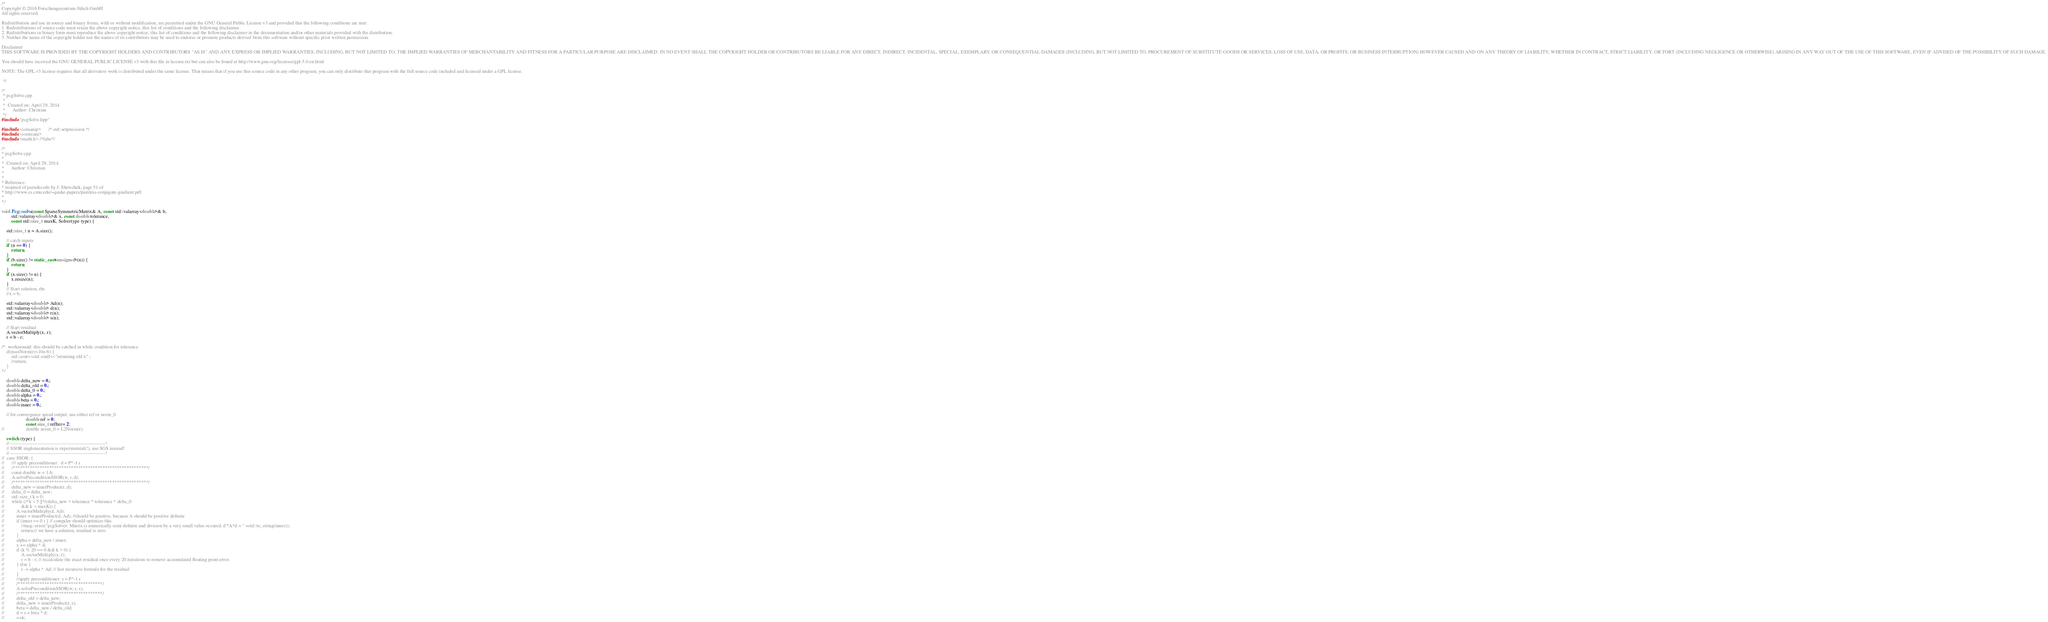Convert code to text. <code><loc_0><loc_0><loc_500><loc_500><_C++_>/*
Copyright © 2016 Forschungszentrum Jülich GmbH
All rights reserved.

Redistribution and use in source and binary forms, with or without modification, are permitted under the GNU General Public License v3 and provided that the following conditions are met:
1. Redistributions of source code must retain the above copyright notice, this list of conditions and the following disclaimer.
2. Redistributions in binary form must reproduce the above copyright notice, this list of conditions and the following disclaimer in the documentation and/or other materials provided with the distribution.
3. Neither the name of the copyright holder nor the names of its contributors may be used to endorse or promote products derived from this software without specific prior written permission.

Disclaimer
THIS SOFTWARE IS PROVIDED BY THE COPYRIGHT HOLDERS AND CONTRIBUTORS "AS IS" AND ANY EXPRESS OR IMPLIED WARRANTIES, INCLUDING, BUT NOT LIMITED TO, THE IMPLIED WARRANTIES OF MERCHANTABILITY AND FITNESS FOR A PARTICULAR PURPOSE ARE DISCLAIMED. IN NO EVENT SHALL THE COPYRIGHT HOLDER OR CONTRIBUTORS BE LIABLE FOR ANY DIRECT, INDIRECT, INCIDENTAL, SPECIAL, EXEMPLARY, OR CONSEQUENTIAL DAMAGES (INCLUDING, BUT NOT LIMITED TO, PROCUREMENT OF SUBSTITUTE GOODS OR SERVICES; LOSS OF USE, DATA, OR PROFITS; OR BUSINESS INTERRUPTION) HOWEVER CAUSED AND ON ANY THEORY OF LIABILITY, WHETHER IN CONTRACT, STRICT LIABILITY, OR TORT (INCLUDING NEGLIGENCE OR OTHERWISE) ARISING IN ANY WAY OUT OF THE USE OF THIS SOFTWARE, EVEN IF ADVISED OF THE POSSIBILITY OF SUCH DAMAGE.

You should have received the GNU GENERAL PUBLIC LICENSE v3 with this file in license.txt but can also be found at http://www.gnu.org/licenses/gpl-3.0.en.html

NOTE: The GPL.v3 license requires that all derivative work is distributed under the same license. That means that if you use this source code in any other program, you can only distribute that program with the full source code included and licensed under a GPL license.

 */

/*
 * pcgSolve.cpp
 *
 *  Created on: April 29, 2014
 *      Author: Christian
 */
#include "pcgSolve.hpp"

#include <iomanip>      /* std::setprecision */
#include <iostream>
#include <math.h> /*fabs*/

/*
* pcgSolve.cpp
*
*  Created on: April 29, 2014
*      Author: Christian
*
*
* Reference:
* inspired of pseudecode by J. Shewchuk, page 51 of
* http://www.cs.cmu.edu/~quake-papers/painless-conjugate-gradient.pdf
*
*/

void Pcg::solve(const SparseSymmetricMatrix& A, const std::valarray<double>& b,
		std::valarray<double>& x, const double tolerance,
		const std::size_t maxK, Solvertype type) {

	std::size_t n = A.size();

	// catch inputs
	if (n == 0) {
		return;
	}
	if (b.size() != static_cast<unsigned>(n)) {
		return;
	}
	if (x.size() != n) {
		x.resize(n);
	}
	// Start solution, rhs
	//x = b;

	std::valarray<double> Ad(n);
	std::valarray<double> d(n);
	std::valarray<double> r(n);
	std::valarray<double> s(n);

	// Start residual
	A.vectorMultiply(x, r);
	r = b - r;

/*	workaround: this should be catched in while condition for tolerance
	if(maxNorm(r)<10e-6) {
		std::cout<<std::endl<<"returning old x" ;
		//return;
	}
*/

	double delta_new = 0.;
	double delta_old = 0.;
	double delta_0 = 0.;
	double alpha = 0.;
	double beta = 0.;
	double inner = 0.;

	// for convergence speed output, use either ref or norm_0
					double ref = 0;
					const size_t refIter= 2;
//					double norm_0 = L2Norm(r);

	switch (type) {
	// -----------------------------------------------------------!
	// SSOR implementation is experimental(!), use SGS instead!
	// -----------------------------------------------------------!
//	case SSOR: {
//		/// apply preconditioner:  d = P^-1 r
//		/********************************************************/
//		const double w = 1.6;
//		A.solvePreconditionSSOR(w, r, d);
//		/********************************************************/
//		delta_new = innerProduct(r, d);
//		delta_0 = delta_new;
//		std::size_t k = 0;
//		while (/*k < 5 ||*/(delta_new > tolerance * tolerance * delta_0
//				&& k < maxK)) {
//			A.vectorMultiply(d, Ad);
//			inner = innerProduct(d, Ad); //should be positive, because A should be positive definite
//			if (inner == 0 ) { // compiler should optimize this
//				//msg::error("pcgSolver: Matrix is numerically semi definite and division by a very small value occured. d'*A*d = " +std::to_string(inner));
//				return;// we have a solution, residual is zero
//			}
//			alpha = delta_new / inner;
//			x += alpha * d;
//			if (k % 20 == 0 && k > 0) {
//				A.vectorMultiply(x, r);
//				r = b - r; // recalculate the exact residual once every 20 iterations to remove accumulated floating point error.
//			} else {
//				r -= alpha * Ad; // fast recursive formula for the residual
//			}
//			//apply preconditioner: s = P^-1 r
//			/***********************************/
//			A.solvePreconditionSSOR(w, r, s);
//			/***********************************/
//			delta_old = delta_new;
//			delta_new = innerProduct(r, s);
//			beta = delta_new / delta_old;
//			d = s + beta * d;
//			++k;</code> 